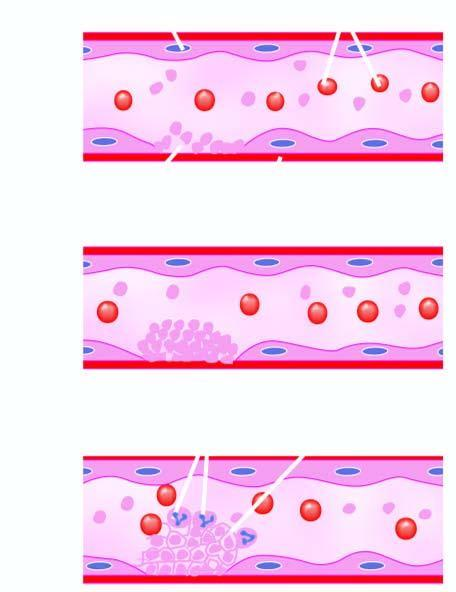does activated coagulation system form fibrin strands in which are entangled some leucocytes and red cells and a tight meshwork is formed called thrombus?
Answer the question using a single word or phrase. Yes 